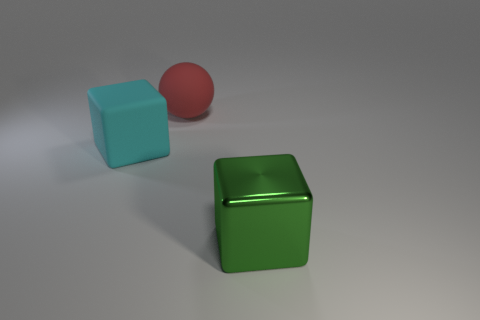Does the big object that is to the right of the big matte sphere have the same shape as the large rubber object that is in front of the big ball?
Offer a terse response. Yes. What number of tiny purple metal cylinders are there?
Provide a short and direct response. 0. There is another cube that is the same size as the matte cube; what color is it?
Offer a terse response. Green. Do the thing left of the red matte thing and the cube that is right of the big rubber ball have the same material?
Provide a short and direct response. No. How big is the cube behind the big block that is in front of the big cyan thing?
Give a very brief answer. Large. There is a large cube on the right side of the big ball; what is it made of?
Offer a terse response. Metal. What number of objects are either large matte objects that are on the right side of the matte block or things right of the red rubber ball?
Offer a terse response. 2. There is a cyan thing that is the same shape as the green metallic thing; what is it made of?
Your answer should be compact. Rubber. Does the big block that is behind the large green block have the same color as the thing that is on the right side of the large matte ball?
Make the answer very short. No. Are there any cyan objects that have the same size as the green metallic thing?
Give a very brief answer. Yes. 